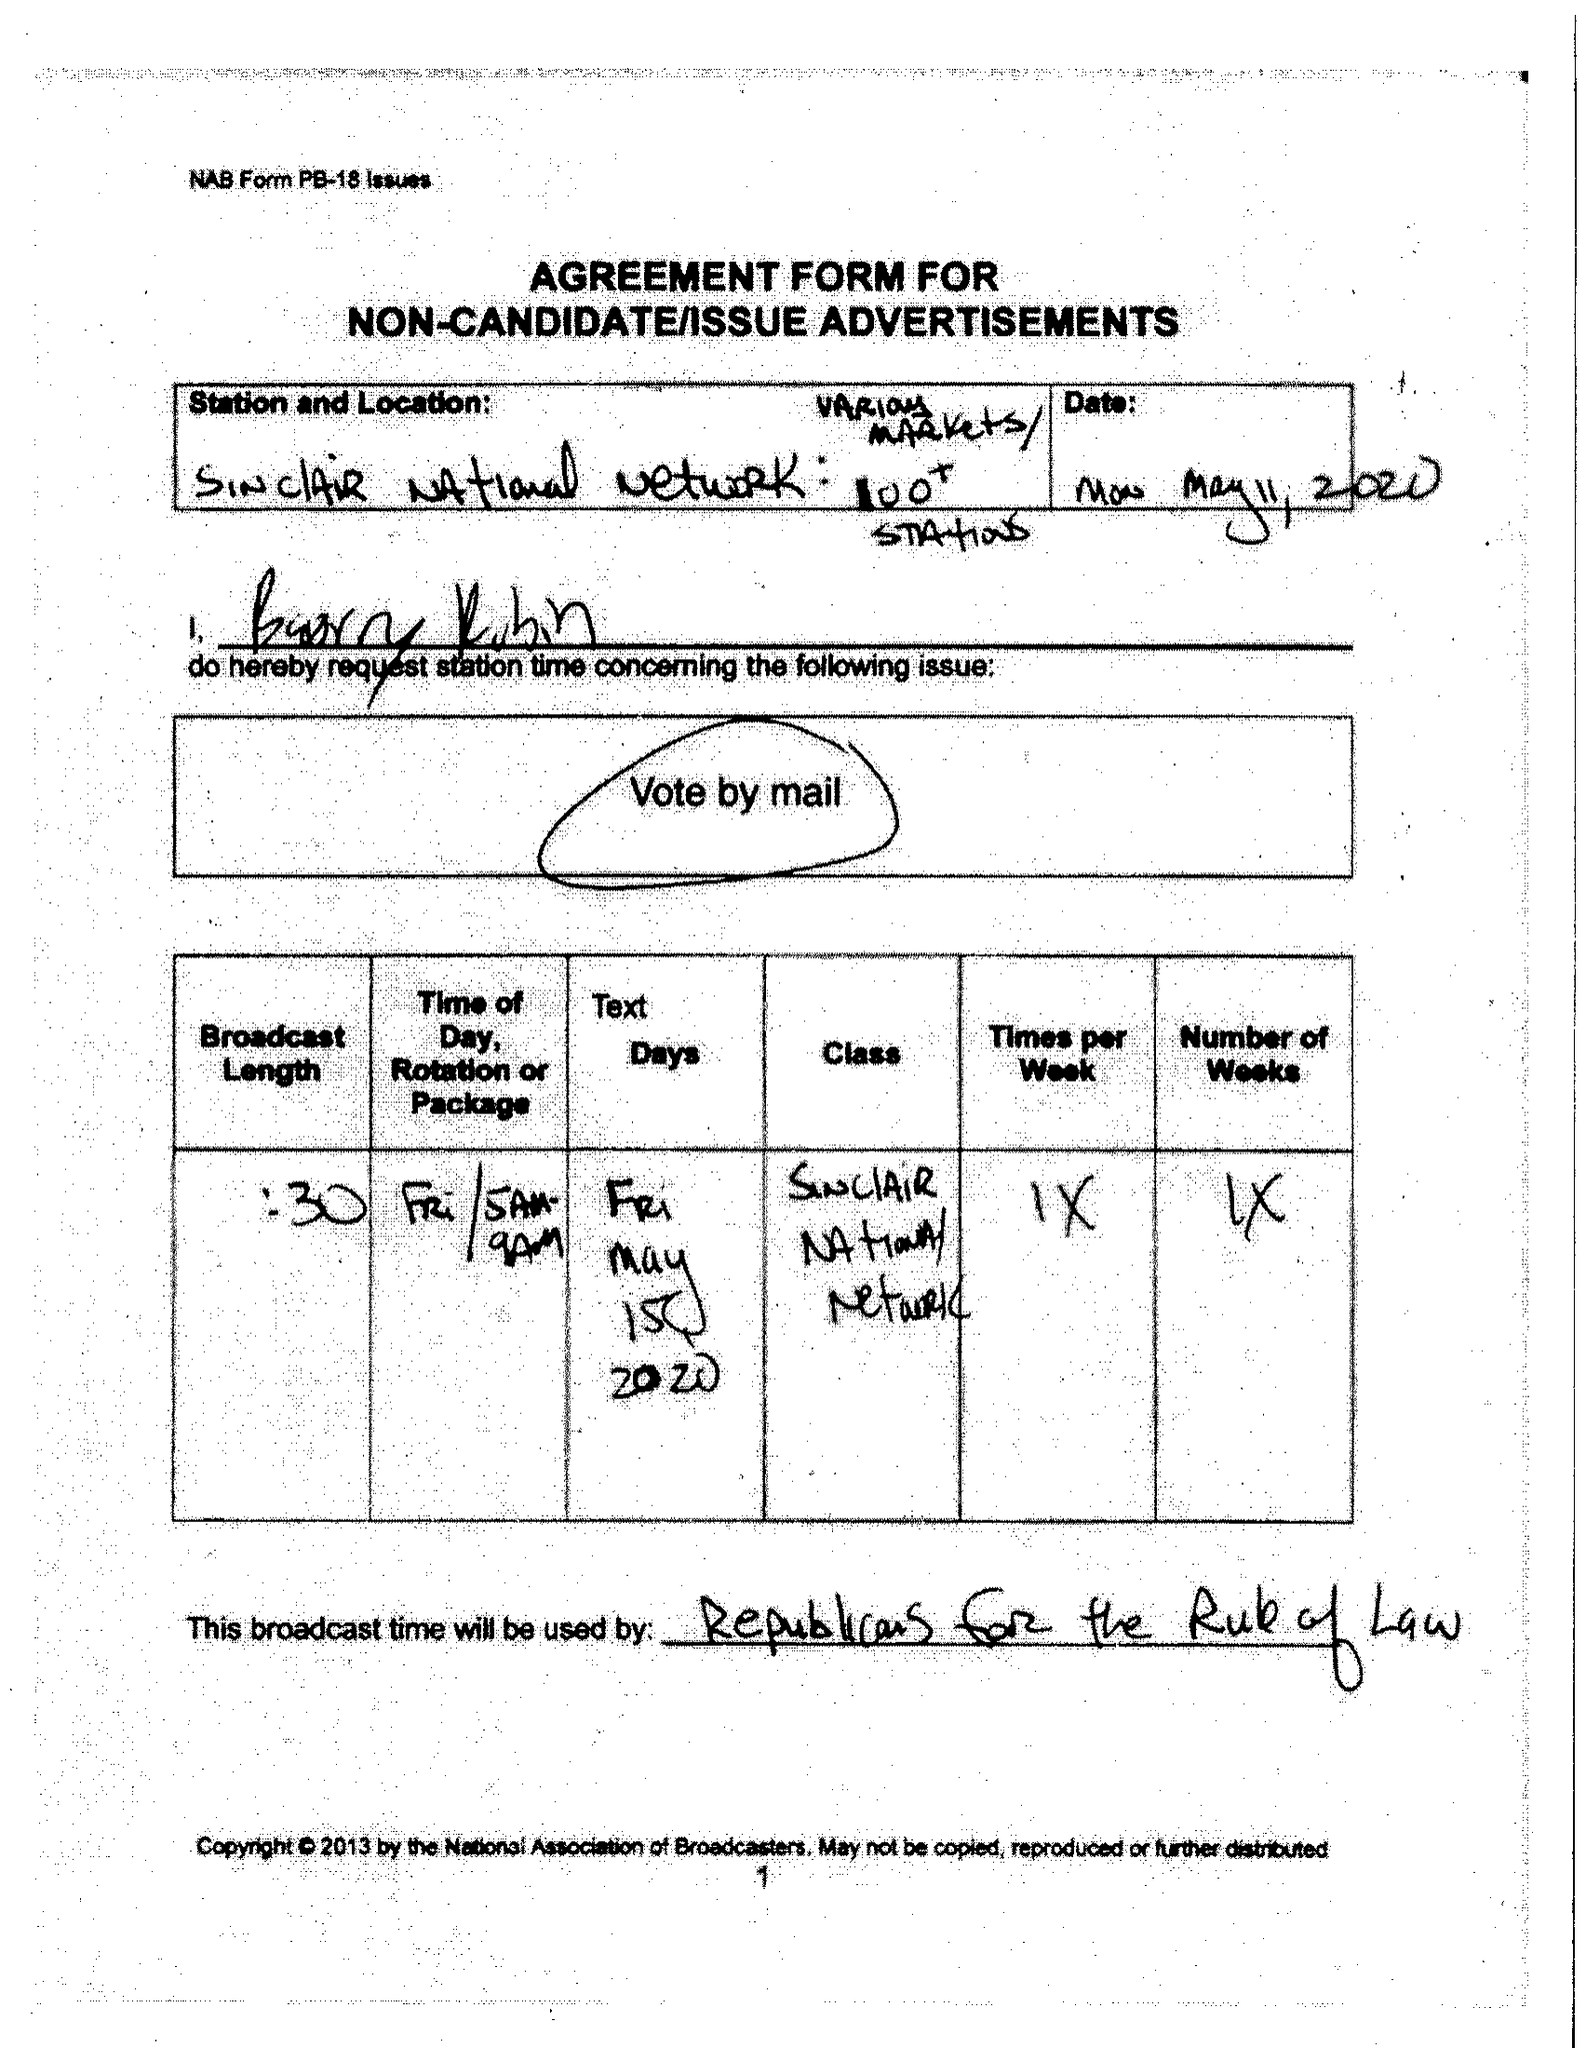What is the value for the flight_from?
Answer the question using a single word or phrase. None 